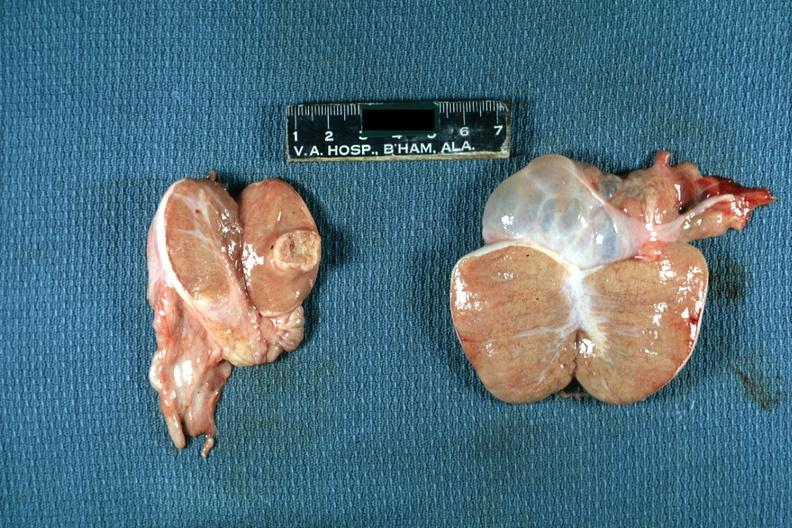how many testicle does this image show discrete yellow mass lesion in hydrocele in other?
Answer the question using a single word or phrase. One 